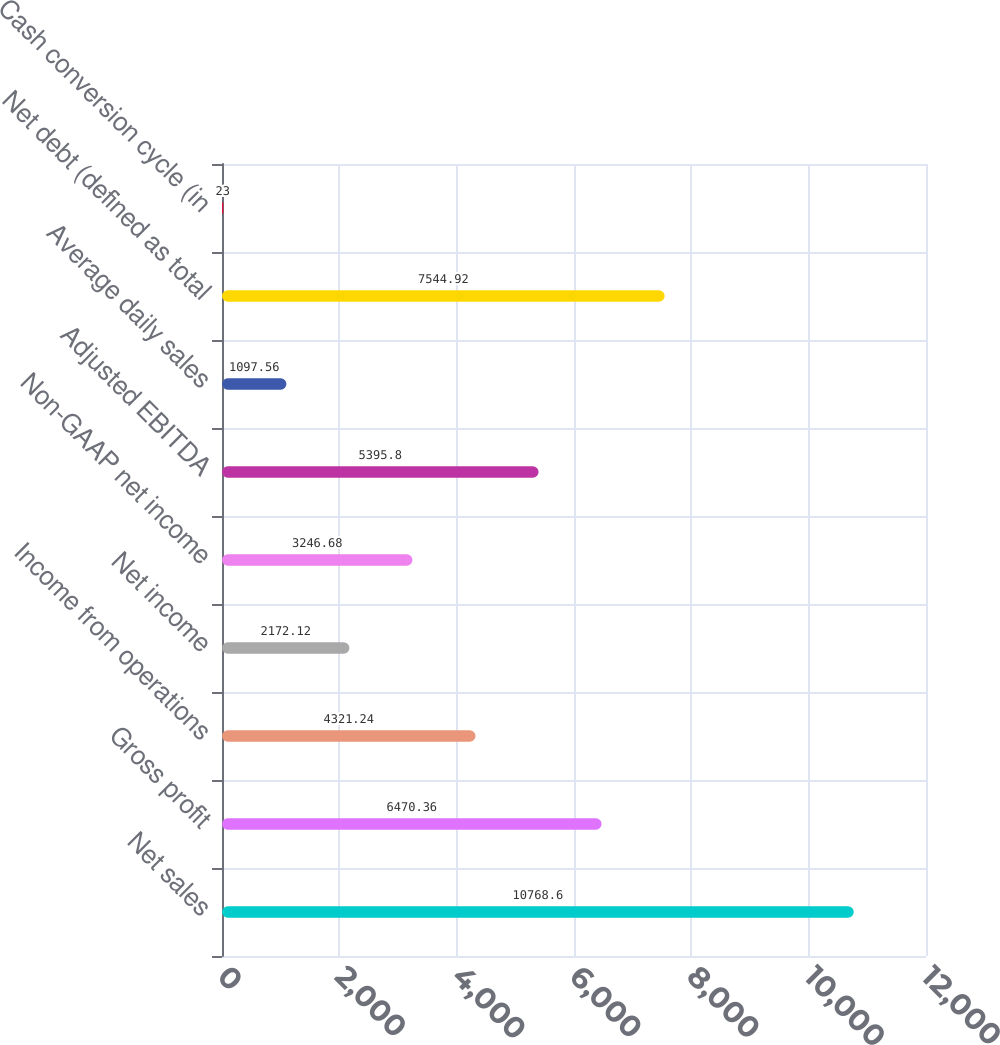<chart> <loc_0><loc_0><loc_500><loc_500><bar_chart><fcel>Net sales<fcel>Gross profit<fcel>Income from operations<fcel>Net income<fcel>Non-GAAP net income<fcel>Adjusted EBITDA<fcel>Average daily sales<fcel>Net debt (defined as total<fcel>Cash conversion cycle (in<nl><fcel>10768.6<fcel>6470.36<fcel>4321.24<fcel>2172.12<fcel>3246.68<fcel>5395.8<fcel>1097.56<fcel>7544.92<fcel>23<nl></chart> 